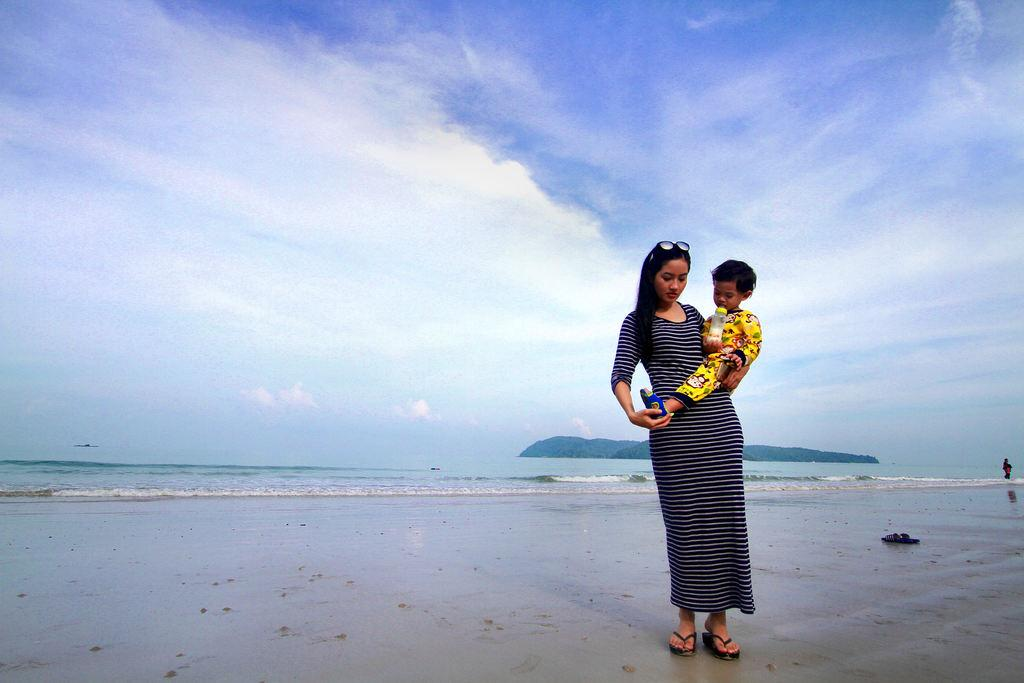What is the woman in the image holding? The woman is holding a baby in the image. What object can be seen near the woman? There is a bottle in the image. What type of clothing or accessory is visible in the image? There are footwear in the image. What type of terrain is present in the image? There is sand and water in the image. How many people are the people are present in the image? There is one person in the image, the woman holding the baby. What can be seen in the background of the image? There is a mountain, sky, and clouds in the background of the image. What type of tools does the carpenter use in the image? There is no carpenter present in the image. Can you tell me how many horses are visible in the image? There are no horses present in the image. 